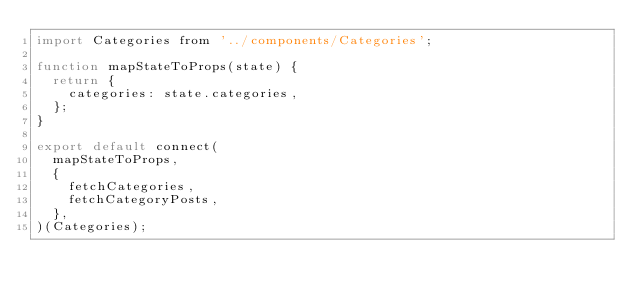Convert code to text. <code><loc_0><loc_0><loc_500><loc_500><_JavaScript_>import Categories from '../components/Categories';

function mapStateToProps(state) {
  return {
    categories: state.categories,
  };
}

export default connect(
  mapStateToProps,
  {
    fetchCategories,
    fetchCategoryPosts,
  },
)(Categories);
</code> 